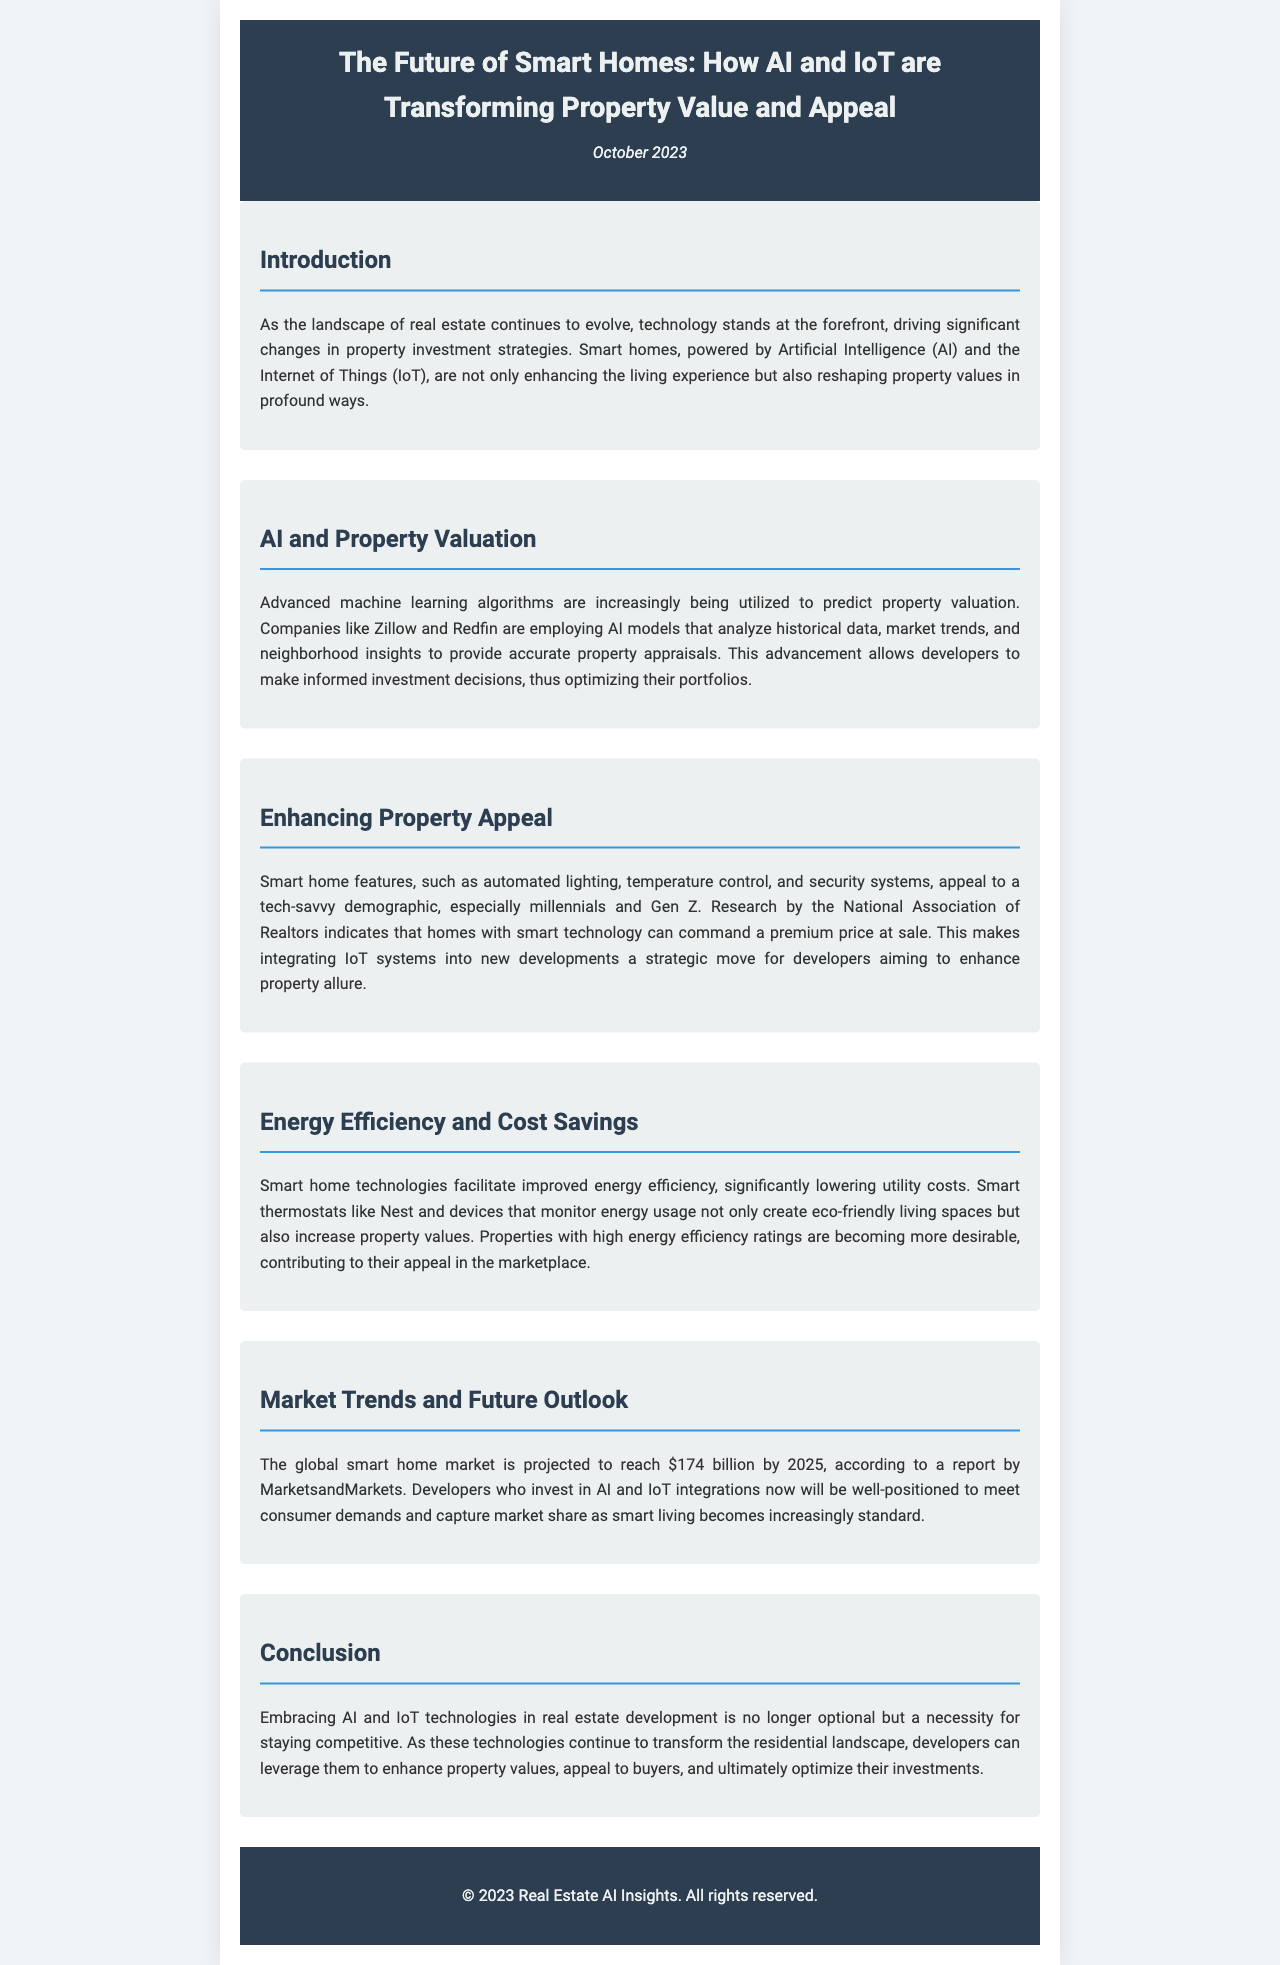What is the projected value of the global smart home market by 2025? The document states that the global smart home market is projected to reach $174 billion by 2025.
Answer: $174 billion Which organization conducted research indicating a premium price for homes with smart technology? The document mentions research conducted by the National Association of Realtors.
Answer: National Association of Realtors What technology can significantly lower utility costs in smart homes? The document refers to smart thermostats like Nest and devices that monitor energy usage.
Answer: Smart thermostats What do advanced machine learning algorithms help predict in real estate? The document explains that advanced machine learning algorithms are utilized to predict property valuation.
Answer: Property valuation According to the document, why is embracing AI and IoT a necessity for developers? The document states that embracing AI and IoT technologies is necessary for staying competitive in the market.
Answer: Staying competitive What demographic is particularly attracted to smart home features? The text indicates that smart home features appeal to a tech-savvy demographic, especially millennials and Gen Z.
Answer: Millennials and Gen Z What is a key benefit of integrating IoT systems into new developments? The document highlights that integrating IoT systems enhances property allure for developers.
Answer: Enhance property allure In which section of the newsletter is the technology's impact on property values discussed? The impact of technology on property values is discussed in the section titled "AI and Property Valuation."
Answer: AI and Property Valuation 